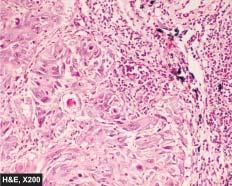re equence of events in the pathogenesis of reversible and irreversible cell injury seen?
Answer the question using a single word or phrase. No 